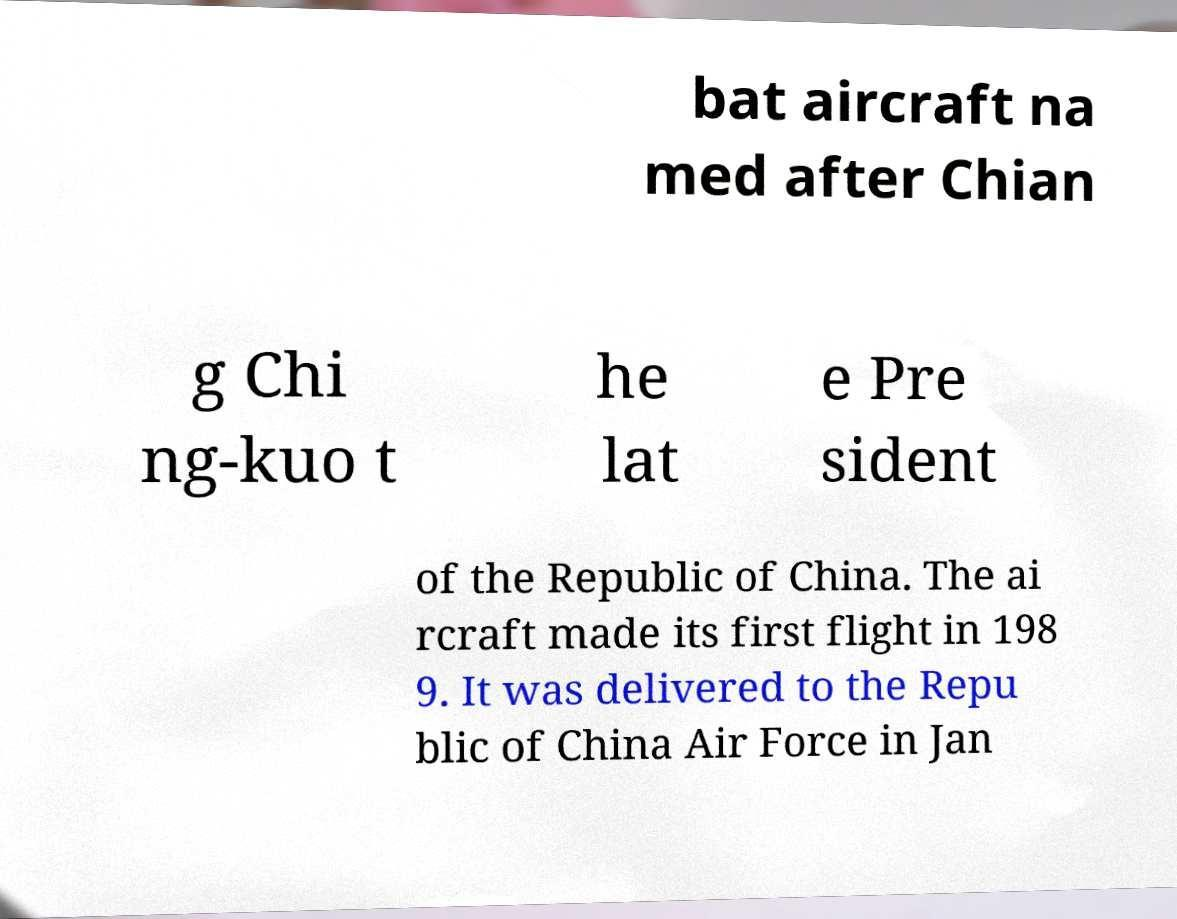Could you assist in decoding the text presented in this image and type it out clearly? bat aircraft na med after Chian g Chi ng-kuo t he lat e Pre sident of the Republic of China. The ai rcraft made its first flight in 198 9. It was delivered to the Repu blic of China Air Force in Jan 